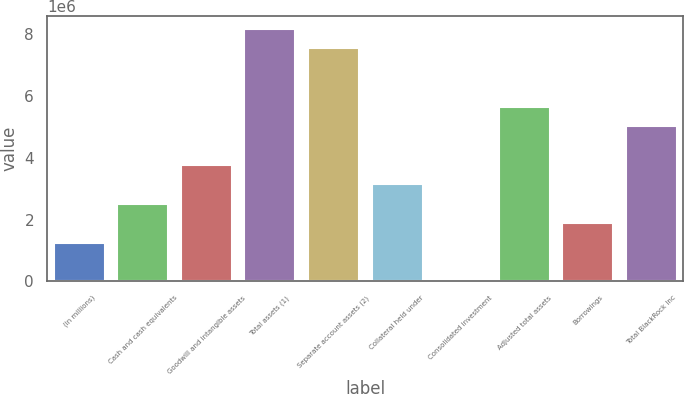Convert chart. <chart><loc_0><loc_0><loc_500><loc_500><bar_chart><fcel>(in millions)<fcel>Cash and cash equivalents<fcel>Goodwill and intangible assets<fcel>Total assets (1)<fcel>Separate account assets (2)<fcel>Collateral held under<fcel>Consolidated investment<fcel>Adjusted total assets<fcel>Borrowings<fcel>Total BlackRock Inc<nl><fcel>1.2581e+06<fcel>2.51563e+06<fcel>3.77315e+06<fcel>8.17448e+06<fcel>7.54572e+06<fcel>3.14439e+06<fcel>580<fcel>5.65943e+06<fcel>1.88686e+06<fcel>5.03067e+06<nl></chart> 